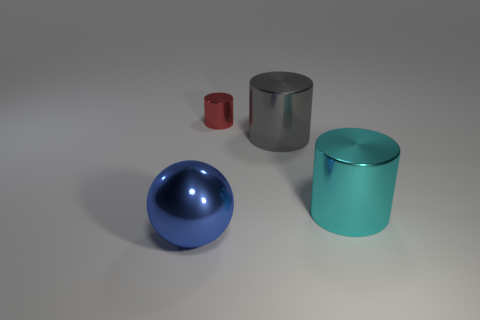Is there any other thing that is the same size as the red object?
Provide a succinct answer. No. Does the gray thing have the same material as the blue object?
Offer a very short reply. Yes. How many objects are metal cylinders left of the large cyan cylinder or metallic things that are behind the big blue ball?
Provide a short and direct response. 3. Are there any other metallic objects of the same size as the cyan shiny thing?
Offer a very short reply. Yes. There is another large metal thing that is the same shape as the big gray shiny thing; what color is it?
Offer a very short reply. Cyan. There is a shiny thing in front of the large cyan cylinder; is there a blue metal ball that is in front of it?
Give a very brief answer. No. Does the large shiny thing that is in front of the large cyan metal cylinder have the same shape as the gray metallic object?
Provide a succinct answer. No. What is the shape of the cyan object?
Give a very brief answer. Cylinder. What number of large gray cylinders have the same material as the ball?
Offer a terse response. 1. There is a big ball; does it have the same color as the big thing behind the cyan shiny thing?
Offer a very short reply. No. 